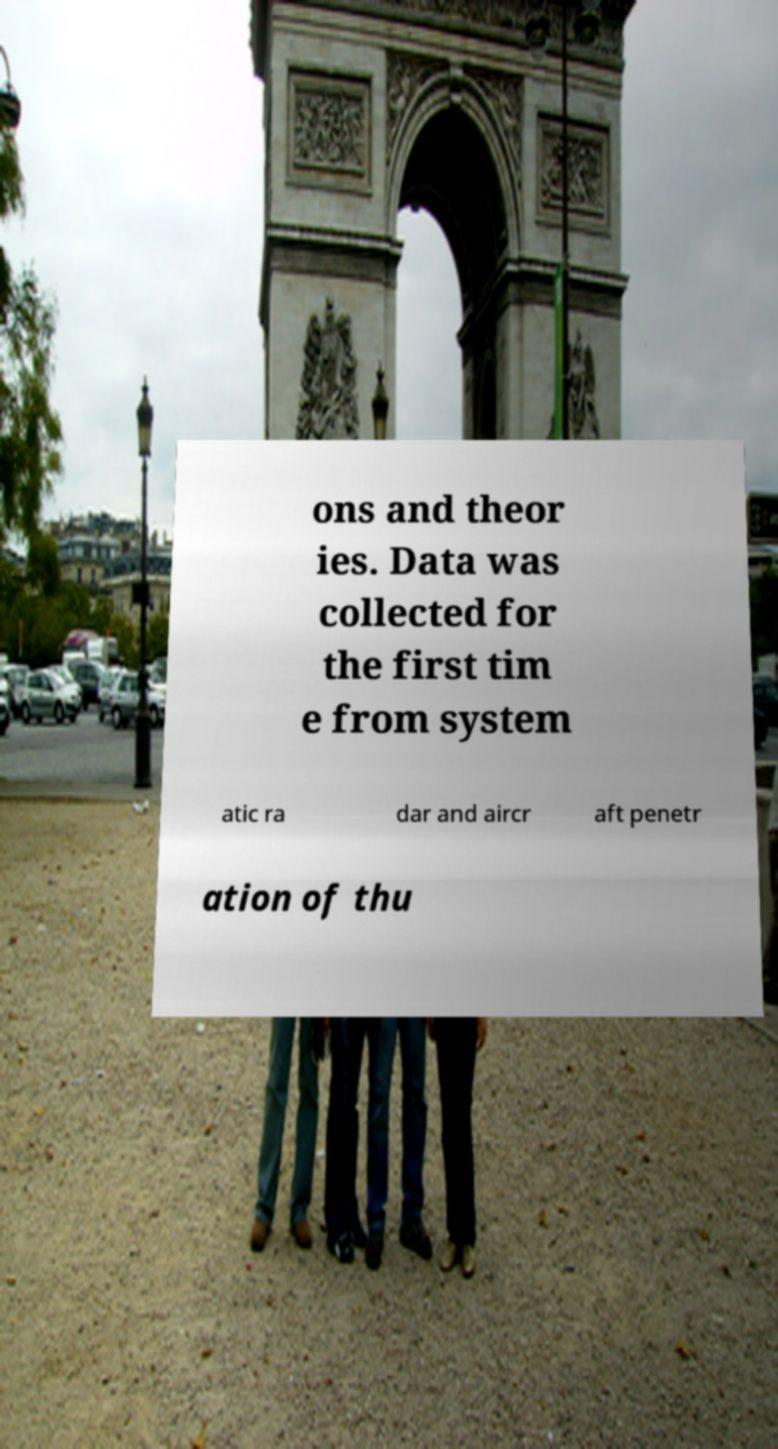There's text embedded in this image that I need extracted. Can you transcribe it verbatim? ons and theor ies. Data was collected for the first tim e from system atic ra dar and aircr aft penetr ation of thu 